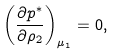Convert formula to latex. <formula><loc_0><loc_0><loc_500><loc_500>\left ( \frac { \partial p ^ { * } } { \partial \rho _ { 2 } } \right ) _ { \mu _ { 1 } } = 0 ,</formula> 